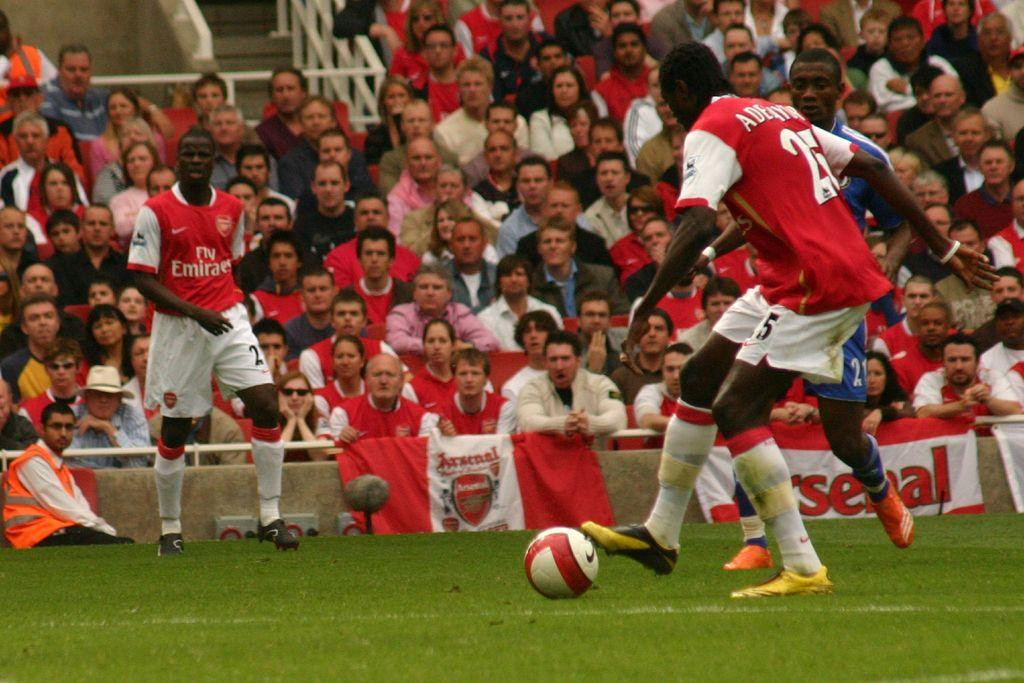What activity are the people in the foreground of the image engaged in? The people in the foreground of the image are playing football on the grassland. What are the people in the background of the image doing? The people in the background of the image are sitting. What can be seen in the background besides the people sitting? There are posters and stairs in the background. How many zippers are visible on the football in the image? There are no zippers on the football in the image, as footballs do not have zippers. What is the amount of way the people in the background are facing? The question is unclear and cannot be answered definitively based on the provided facts. The people in the background are simply sitting, and their facing direction is not specified. 